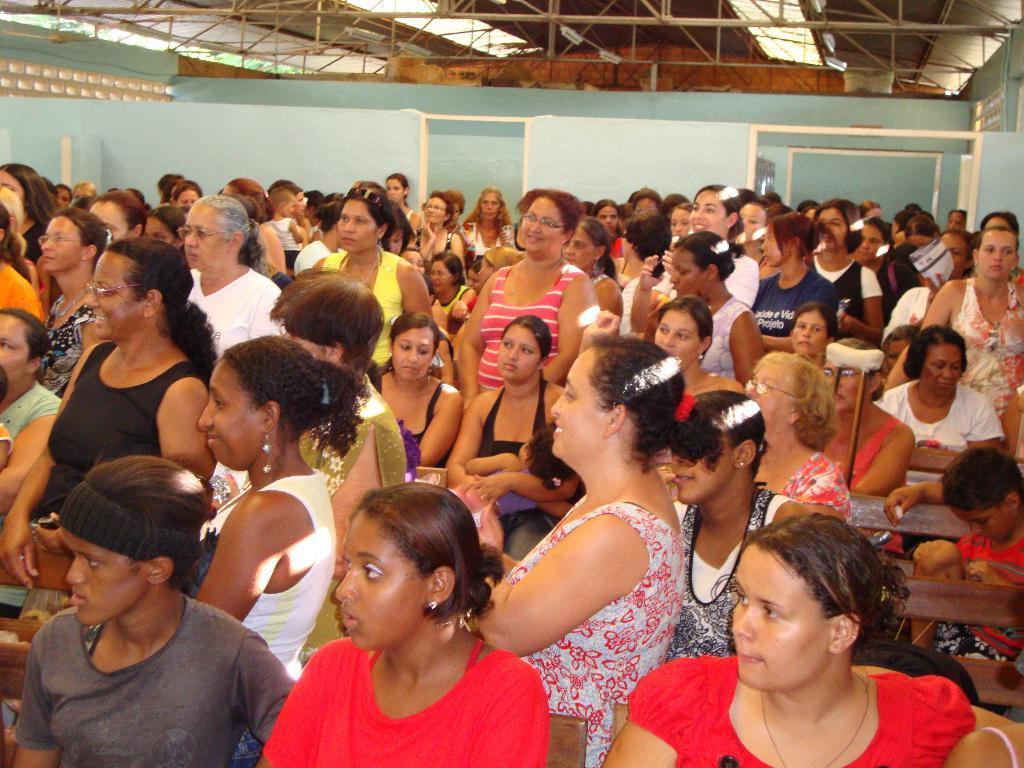Describe this image in one or two sentences. In the foreground of the image there are people sitting on benches. In the background of the image there are people standing. There is wall. At the top of the image there is ceiling with rods. 